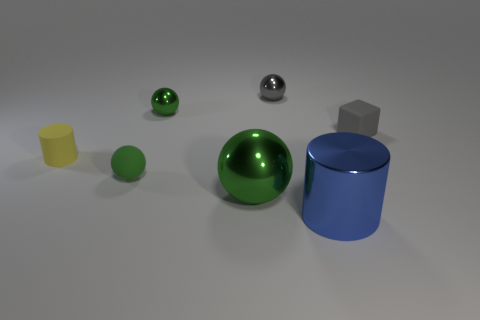Subtract all yellow cubes. How many green spheres are left? 3 Add 2 green balls. How many objects exist? 9 Subtract all purple spheres. Subtract all blue blocks. How many spheres are left? 4 Subtract all blocks. How many objects are left? 6 Subtract all purple metallic cylinders. Subtract all yellow cylinders. How many objects are left? 6 Add 2 tiny green metal objects. How many tiny green metal objects are left? 3 Add 4 green shiny objects. How many green shiny objects exist? 6 Subtract 0 green cylinders. How many objects are left? 7 